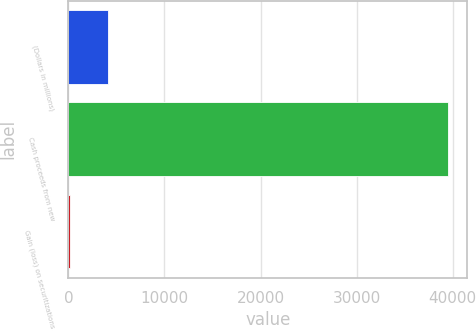Convert chart to OTSL. <chart><loc_0><loc_0><loc_500><loc_500><bar_chart><fcel>(Dollars in millions)<fcel>Cash proceeds from new<fcel>Gain (loss) on securitizations<nl><fcel>4143.4<fcel>39526<fcel>212<nl></chart> 